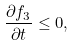<formula> <loc_0><loc_0><loc_500><loc_500>\frac { \partial f _ { 3 } } { \partial t } \leq 0 ,</formula> 